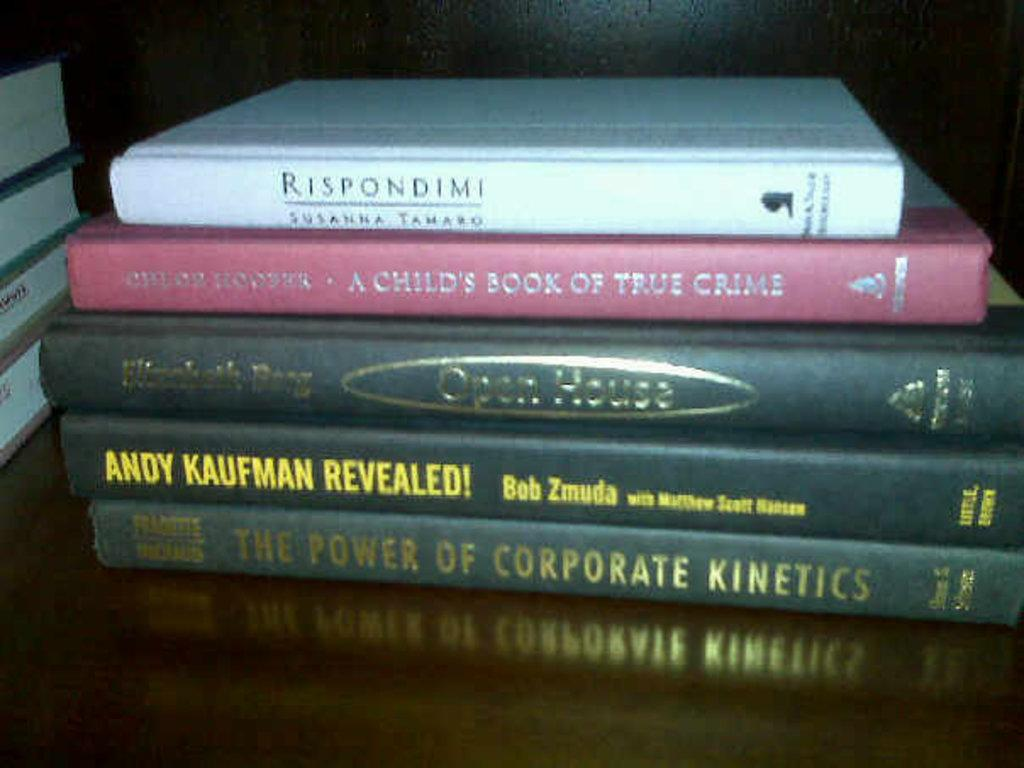<image>
Relay a brief, clear account of the picture shown. A hardcover book about Andy Kaufman sits in a stack with four other hardback books. 